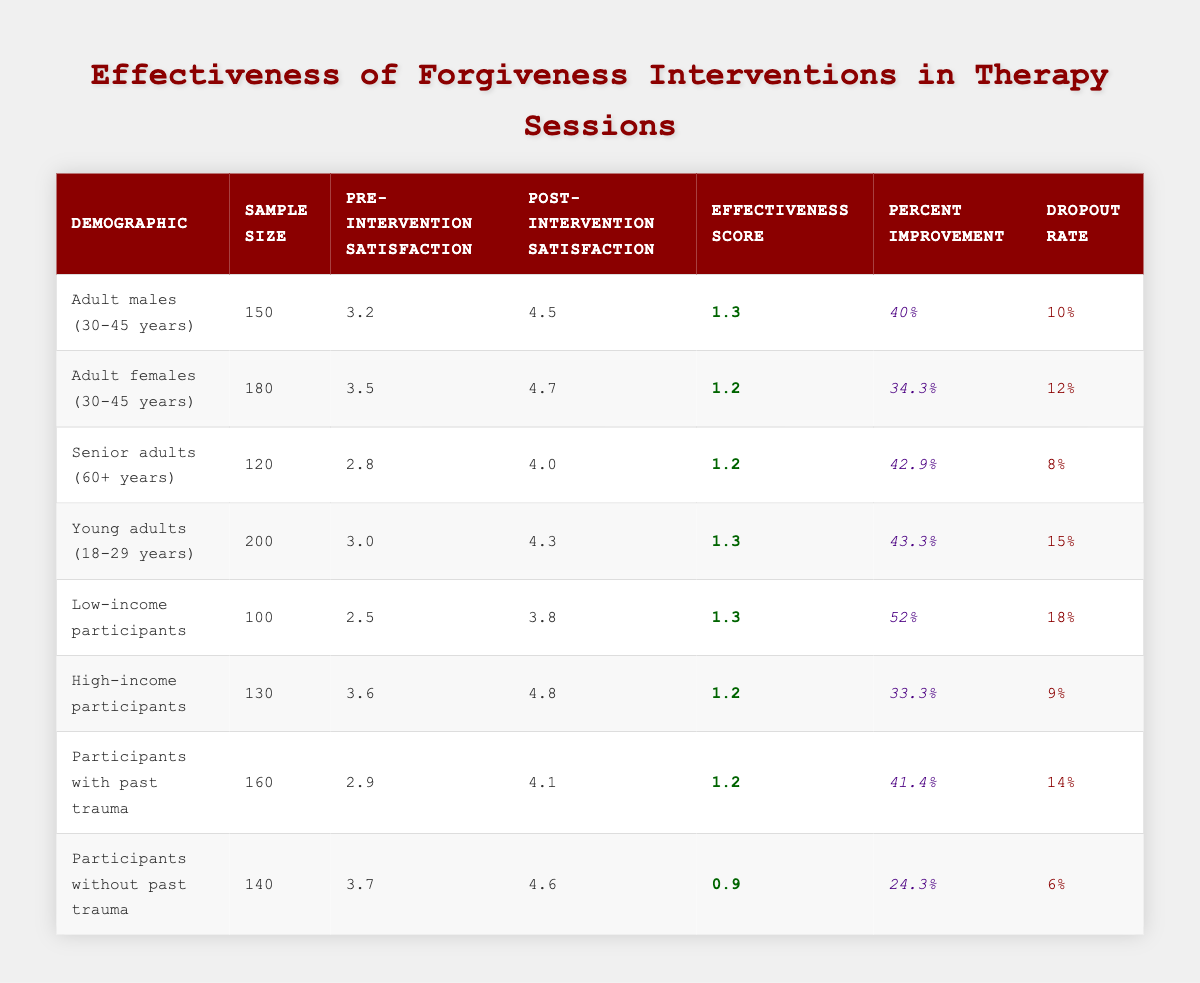What is the effectiveness score for low-income participants? The effectiveness score for low-income participants is directly listed in the table under the respective demographic row. The value is 1.3.
Answer: 1.3 Which demographic has the highest percent improvement after the forgiveness intervention? By examining the percent improvement column in the table, the low-income participants have the highest percent improvement at 52%.
Answer: 52% Is the dropout rate for participants without past trauma lower than that for participants with past trauma? The table indicates that the dropout rate for participants without past trauma is 6%, while for participants with past trauma it is 14%. Since 6% is less than 14%, the answer is yes.
Answer: Yes What is the average pre-intervention satisfaction score across all demographics? To calculate the average, sum all pre-intervention satisfaction scores (3.2 + 3.5 + 2.8 + 3.0 + 2.5 + 3.6 + 2.9 + 3.7 = 23.2) and divide by the number of demographics (8). So, 23.2/8 = 2.9.
Answer: 2.9 What is the difference in post-intervention satisfaction between young adults and senior adults? Looking at the post-intervention satisfaction for young adults, which is 4.3, and for senior adults, which is 4.0, we find the difference is 4.3 - 4.0 = 0.3.
Answer: 0.3 Do adult females (30-45 years) or high-income participants have a higher pre-intervention satisfaction score? The pre-intervention satisfaction for adult females (3.5) is compared to high-income participants (3.6). Adult females have a lower score than high-income participants, so they do not have the higher score. The answer is no.
Answer: No How many participants drop out from the intervention among young adults? The dropout rate for young adults is provided in the table as 15%. To find the number of participants who drop out, calculate using the sample size (200). Thus, 15% of 200 is calculated as 200 * 0.15 = 30.
Answer: 30 Which demographic shows the least satisfaction after the intervention? Assessing the post-intervention satisfaction scores, the senior adults have the lowest value at 4.0, compared to others in the table.
Answer: 4.0 